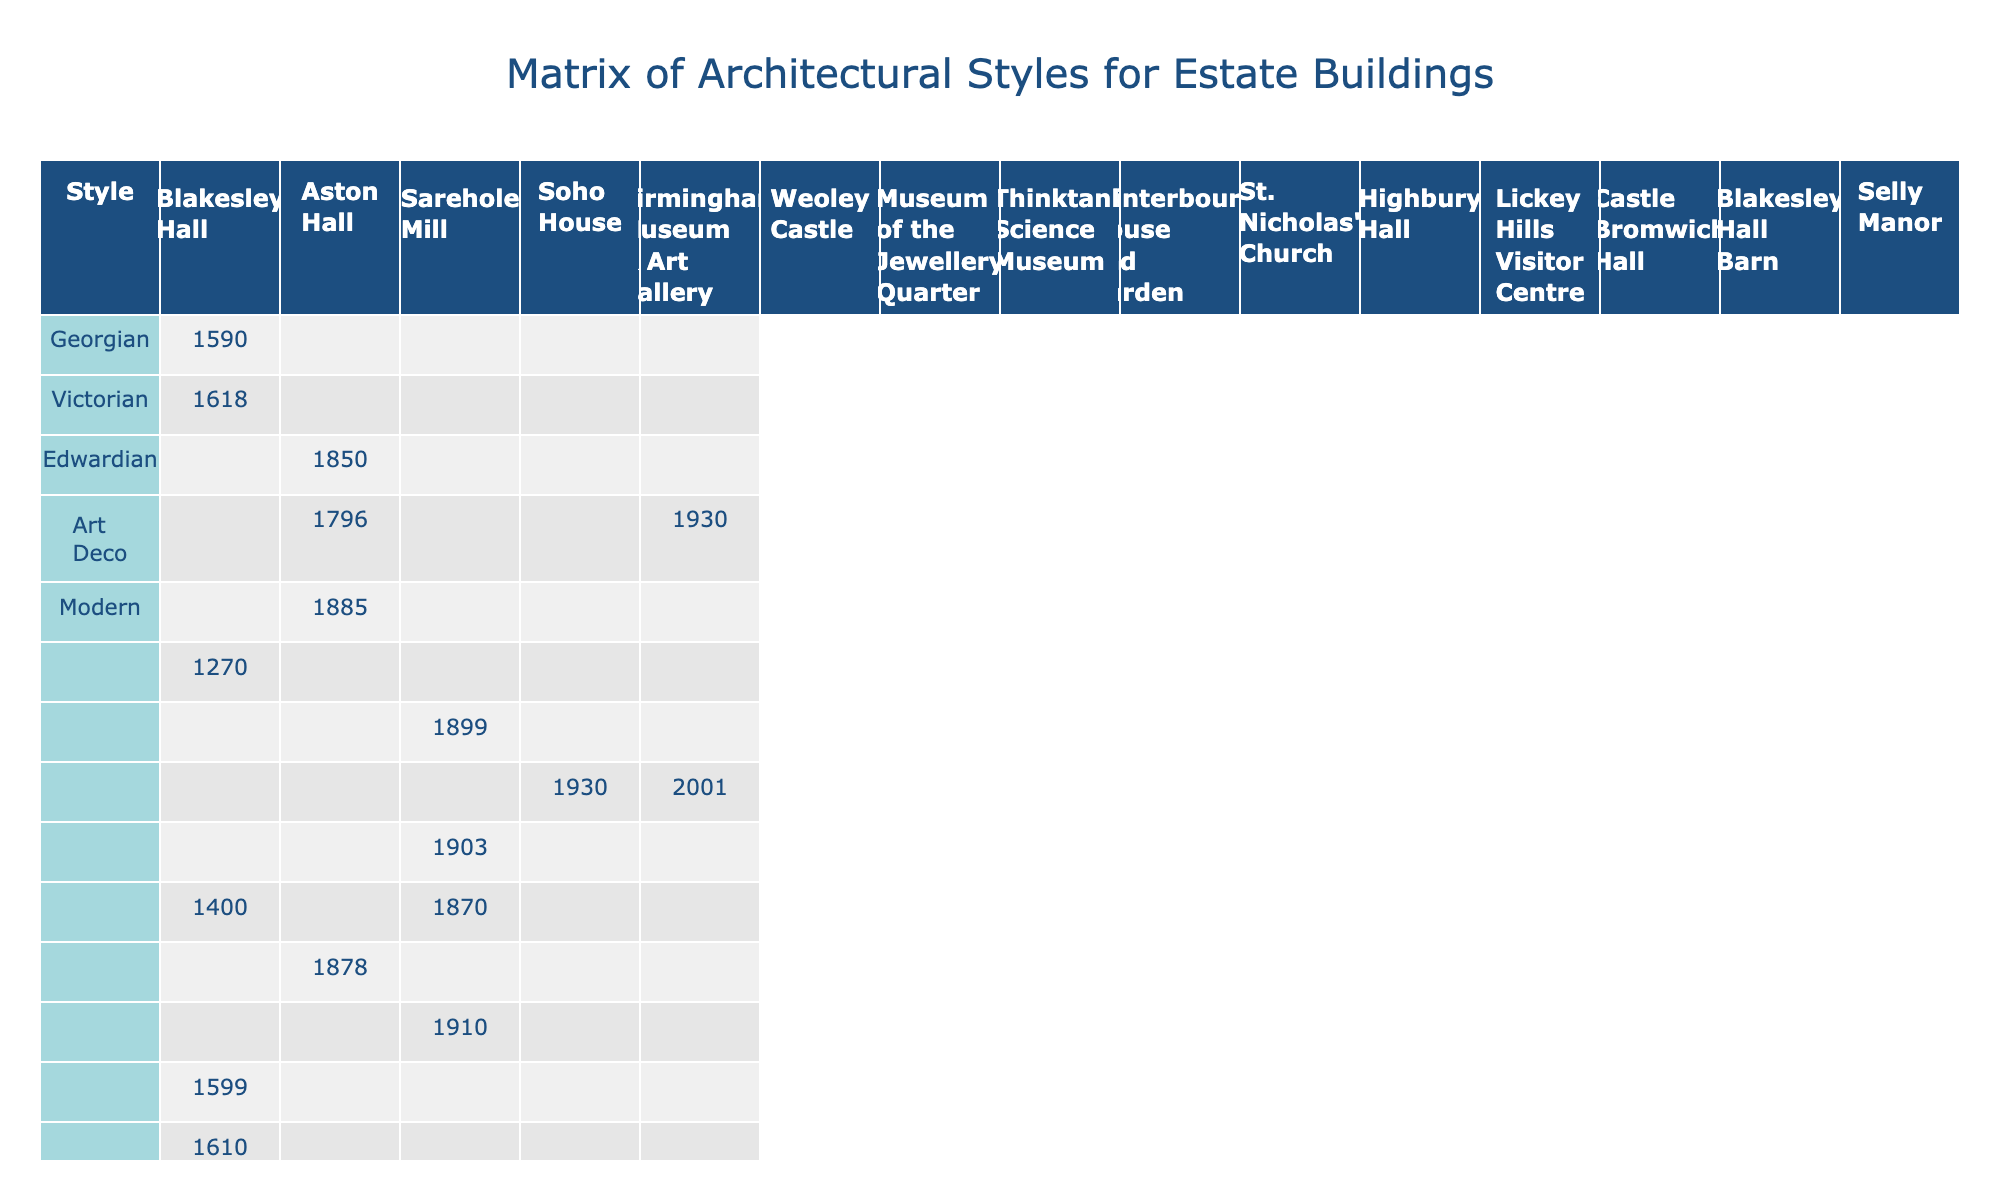What is the last renovation year for Sarehole Mill? By checking the "Last Renovation" column for Sarehole Mill, we find the year listed is 2012.
Answer: 2012 Which building has the latest modern architectural style? Looking at the "Modern" column, the only building with a modern style is Thinktank Science Museum, renovated in 2019, which is the latest renovation date listed overall.
Answer: Thinktank Science Museum How many buildings have a Victorian architecture style? By examining the table, I count two buildings: Sarehole Mill and Birmingham Museum & Art Gallery, both of which have Victorian years listed.
Answer: 2 Is it true that Blakesley Hall was renovated in 2002? The table indicates that the last renovation year for Blakesley Hall is indeed 2002, so this statement is true.
Answer: True Which is the earliest construction date among the buildings listed? By looking through the dates in the "Last Renovation" and "Building Name," I find Weoley Castle constructed in 1270, which is the earliest date noted.
Answer: Weoley Castle (1270) Is there any building that has both Georgian and Victorian styles? Upon reviewing the table, no building appears to have both styles listed, as they are mutually exclusive in this dataset.
Answer: No What is the average last renovation year for all buildings listed? Adding the last renovation years (2002, 2009, 2012, 2018, 2015, 2005, 2010, 2008, 2014, 2017, 2011, 2007, 2003, 2016) gives a total of 2003, and with 14 buildings, the average is 2003/14, which rounds to 2010.
Answer: 2010 How many buildings have undergone renovations in the 2000s? Counting the years in the "Last Renovation" column, the buildings renovated in the 2000s are Blakesley Hall, Aston Hall, Sarehole Mill, Soho House, Birmingham Museum & Art Gallery, Weoley Castle, Museum of the Jewellery Quarter, Thinktank Science Museum, Winterbourne House and Garden, St. Nicholas' Church, Highbury Hall, Lickey Hills Visitor Centre, Castle Bromwich Hall, Blakesley Hall Barn, and Selly Manor, totaling 14.
Answer: 14 Which architectural style is represented on the most buildings? Evaluating the columns for architectural styles, the Georgian style has 4 buildings, while the Victorian, Edwardian, Art Deco, and Modern styles have fewer, making Georgian the most represented.
Answer: Georgian Are there any buildings that were last renovated before 2005? After reviewing the "Last Renovation" column, we find Blakesley Hall (2002), Aston Hall (2009), and Blakesley Hall Barn (2003) were renovated before 2005.
Answer: Yes 